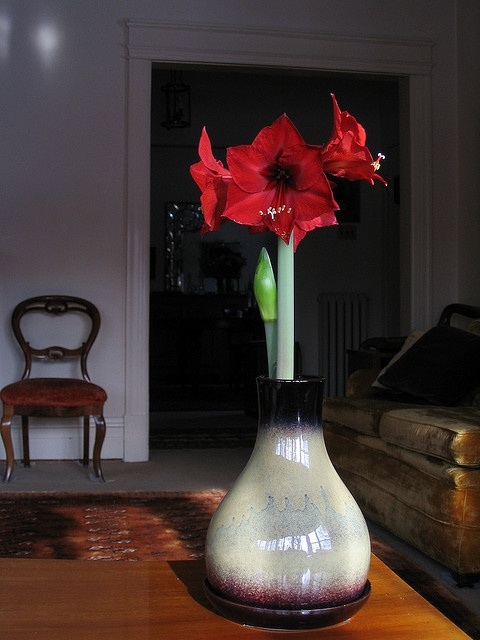Describe the objects in this image and their specific colors. I can see vase in gray, darkgray, lightgray, and black tones, couch in gray, black, maroon, and olive tones, and chair in gray, black, and maroon tones in this image. 